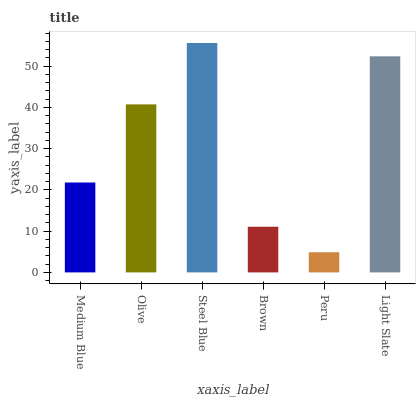Is Peru the minimum?
Answer yes or no. Yes. Is Steel Blue the maximum?
Answer yes or no. Yes. Is Olive the minimum?
Answer yes or no. No. Is Olive the maximum?
Answer yes or no. No. Is Olive greater than Medium Blue?
Answer yes or no. Yes. Is Medium Blue less than Olive?
Answer yes or no. Yes. Is Medium Blue greater than Olive?
Answer yes or no. No. Is Olive less than Medium Blue?
Answer yes or no. No. Is Olive the high median?
Answer yes or no. Yes. Is Medium Blue the low median?
Answer yes or no. Yes. Is Light Slate the high median?
Answer yes or no. No. Is Olive the low median?
Answer yes or no. No. 